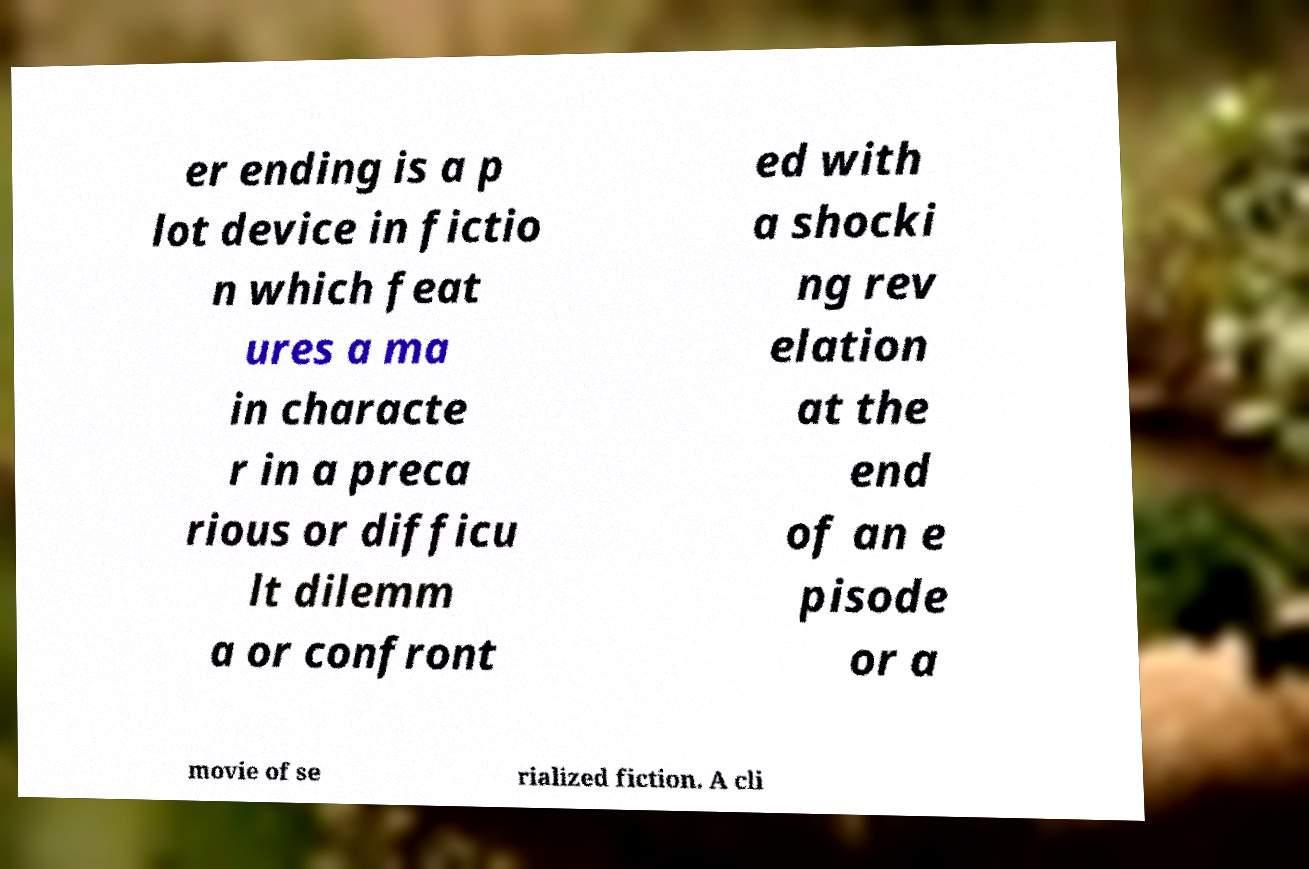Could you extract and type out the text from this image? er ending is a p lot device in fictio n which feat ures a ma in characte r in a preca rious or difficu lt dilemm a or confront ed with a shocki ng rev elation at the end of an e pisode or a movie of se rialized fiction. A cli 